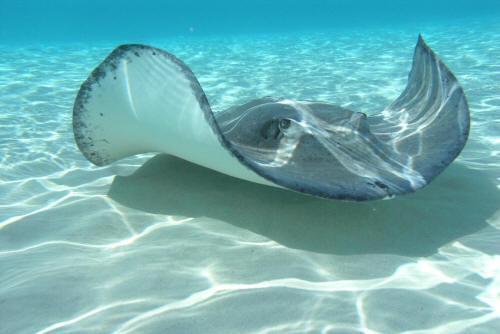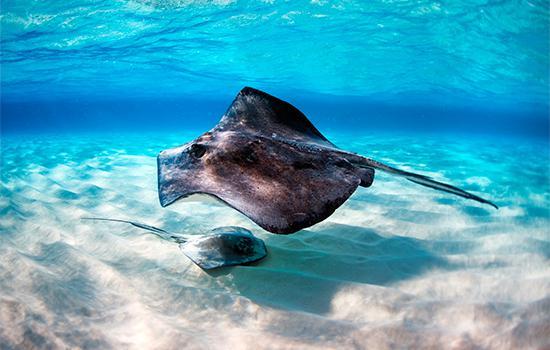The first image is the image on the left, the second image is the image on the right. Considering the images on both sides, is "All of the stingrays are near the ocean floor." valid? Answer yes or no. Yes. 